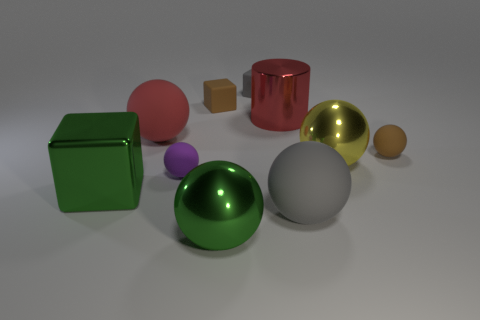There is a small sphere that is behind the metal ball that is behind the big gray thing; what number of matte things are behind it?
Give a very brief answer. 3. There is a red object that is the same shape as the yellow shiny object; what material is it?
Provide a short and direct response. Rubber. Is there anything else that has the same material as the tiny gray block?
Your answer should be very brief. Yes. What color is the large metallic object in front of the big gray rubber object?
Offer a very short reply. Green. Does the big red sphere have the same material as the red object to the right of the purple rubber thing?
Provide a succinct answer. No. What is the big green ball made of?
Make the answer very short. Metal. There is a green object that is made of the same material as the green cube; what shape is it?
Make the answer very short. Sphere. What number of other things are the same shape as the tiny gray object?
Provide a succinct answer. 2. How many large green metal blocks are left of the large red sphere?
Your response must be concise. 1. Do the red rubber thing behind the purple matte thing and the gray thing to the left of the metal cylinder have the same size?
Ensure brevity in your answer.  No. 